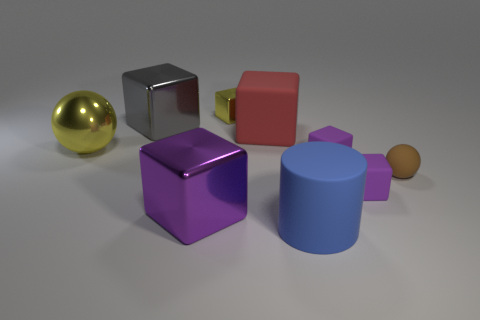There is a block that is on the right side of the yellow block and in front of the small rubber sphere; what is its color? purple 